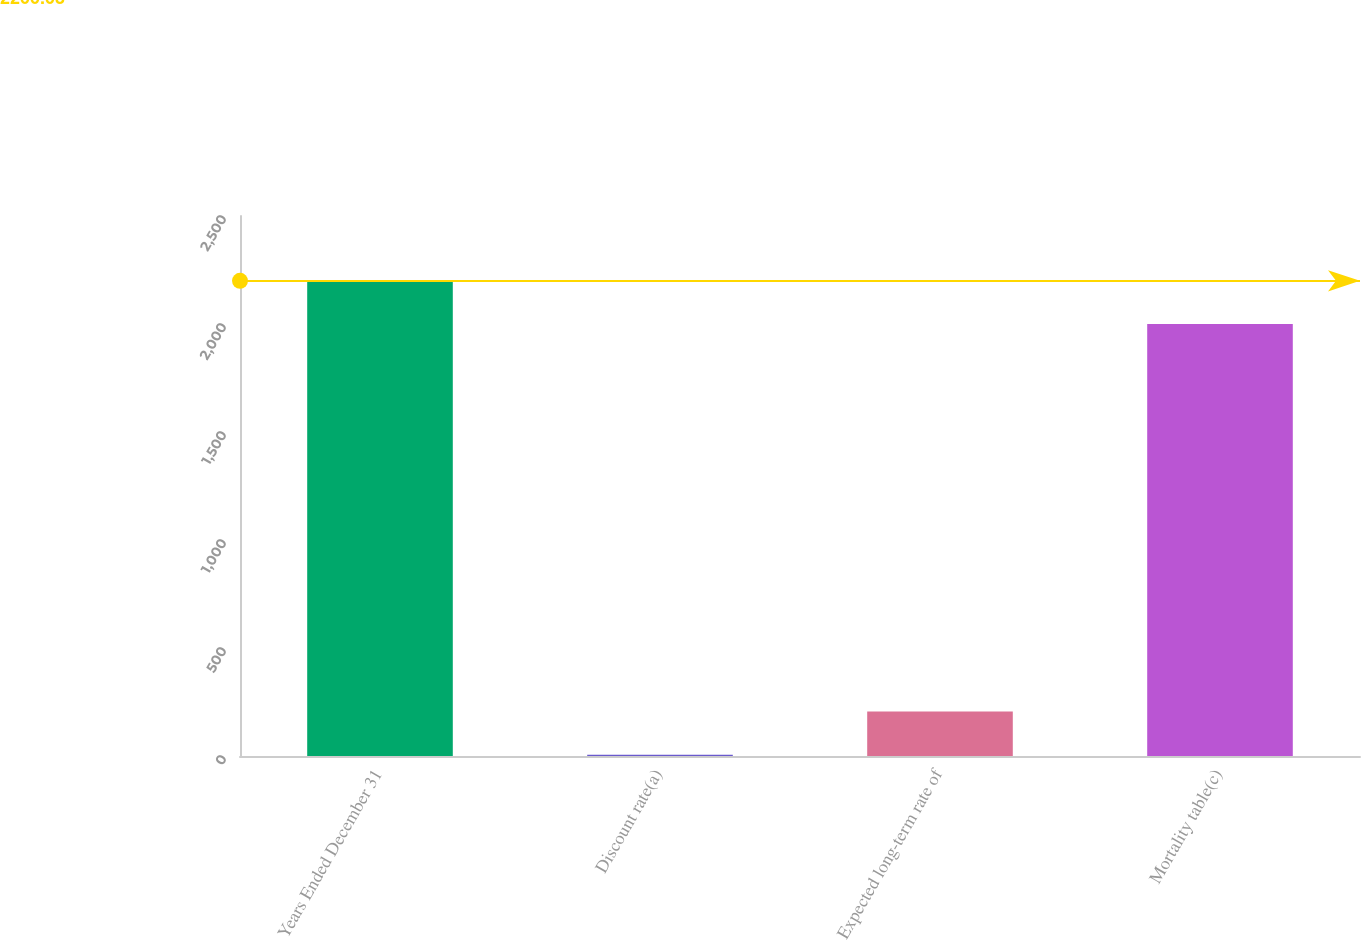Convert chart to OTSL. <chart><loc_0><loc_0><loc_500><loc_500><bar_chart><fcel>Years Ended December 31<fcel>Discount rate(a)<fcel>Expected long-term rate of<fcel>Mortality table(c)<nl><fcel>2200.03<fcel>5.65<fcel>205.69<fcel>2000<nl></chart> 